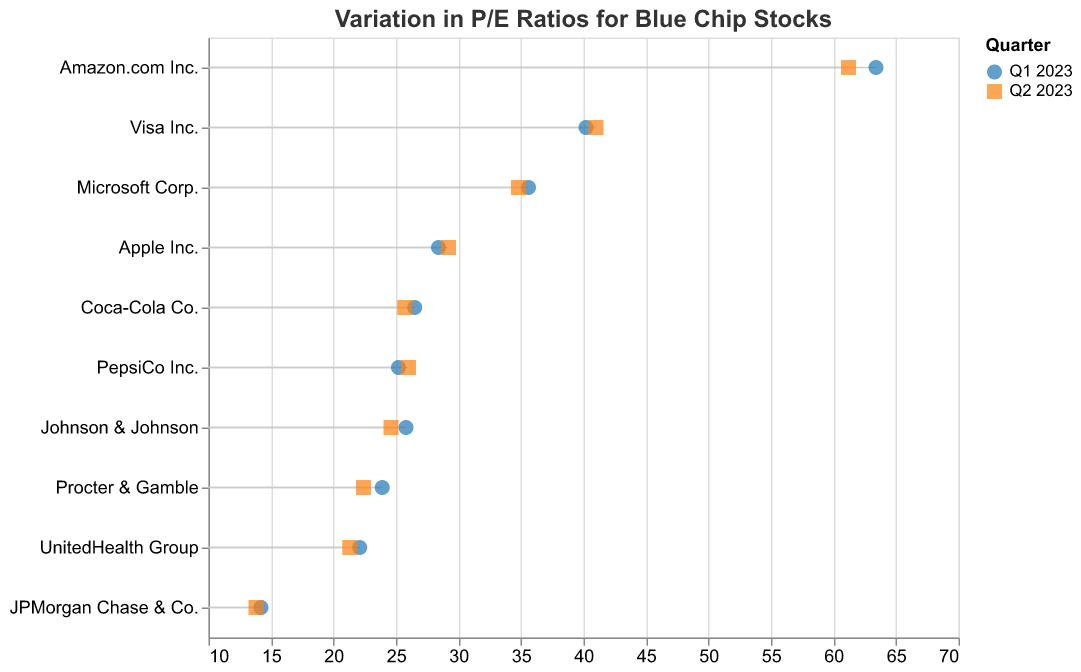What is the title of the plot? The title of the plot is usually placed at the top of the visualization. In this case, the title text specifies "Variation in P/E Ratios for Blue Chip Stocks Between Fiscal Quarters".
Answer: Variation in P/E Ratios for Blue Chip Stocks Which company had the highest P/E Ratio in Q1 2023? Looking at the data points in the Q1 2023, Amazon.com Inc. has the P/E Ratio of 63.4, which is the highest among all companies listed.
Answer: Amazon.com Inc How much did the P/E Ratio for Apple Inc. change from Q1 to Q2 2023? Referring to the data points for Apple Inc., its P/E Ratio was 28.4 in Q1 and 29.2 in Q2. The change is calculated as 29.2 - 28.4.
Answer: 0.8 Which quarter had a higher P/E Ratio for Visa Inc.? The data points for Visa Inc. show a P/E Ratio of 40.2 in Q1 and 41.0 in Q2. Since 41.0 is greater, Q2 has the higher P/E Ratio.
Answer: Q2 2023 What is the average P/E Ratio for Microsoft Corp. between Q1 and Q2 2023? Microsoft Corp. had a P/E Ratio of 35.6 in Q1 and 34.8 in Q2. The average is calculated as (35.6 + 34.8)/2.
Answer: 35.2 Which company had the largest drop in P/E Ratio from Q1 to Q2 2023? To find the largest drop, we examine the P/E Ratio changes of each company. Johnson & Johnson's P/E Ratio dropped from 25.8 to 24.6, a change of 25.8 - 24.6 = 1.2. Comparing with other drops: Apple Inc. (0.8), Microsoft Corp. (0.8), Amazon.com Inc. (2.2), Procter & Gamble (1.5), JPMorgan Chase & Co. (0.4), UnitedHealth Group (0.8), Coca-Cola Co. (0.8), PepsiCo Inc. (-0.8), Amazon.com Inc. has the largest drop.
Answer: Amazon.com Inc Which companies saw an increase in their P/E Ratios from Q1 to Q2 2023? By examining the data, we see the increase for Apple Inc. (0.8), Visa Inc. (0.8), and PepsiCo Inc. (0.8). Hence, these companies saw an increase.
Answer: Apple Inc., Visa Inc., PepsiCo Inc What are the two companies with the lowest P/E Ratios in Q2 2023? From the Q2 data, the companies with the lowest P/E Ratios are JPMorgan Chase & Co. (13.8) and UnitedHealth Group (21.3).
Answer: JPMorgan Chase & Co., UnitedHealth Group What is the range of P/E Ratios for blue-chip stocks in Q1 2023? To find the range, we subtract the smallest P/E Ratio in Q1 from the largest. The smallest is JPMorgan Chase & Co. (14.2) and the largest is Amazon.com Inc. (63.4). The range is 63.4 - 14.2.
Answer: 49.2 